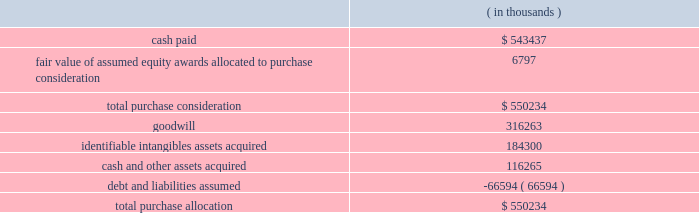Synopsys , inc .
Notes to consolidated financial statements 2014continued acquisition of magma design automation , inc .
( magma ) on february 22 , 2012 , the company acquired all outstanding shares of magma , a chip design software provider , at a per-share price of $ 7.35 .
Additionally , the company assumed unvested restricted stock units ( rsus ) and stock options , collectively called 201cequity awards . 201d the aggregate purchase price was approximately $ 550.2 million .
This acquisition enables the company to more rapidly meet the needs of leading-edge semiconductor designers for more sophisticated design tools .
As of october 31 , 2012 , the total purchase consideration and the preliminary purchase price allocation were as follows: .
Goodwill of $ 316.3 million , which is not deductible for tax purposes , primarily resulted from the company 2019s expectation of sales growth and cost synergies from the integration of magma 2019s technology and operations with the company 2019s technology and operations .
Identifiable intangible assets , consisting primarily of technology , customer relationships , backlog and trademarks , were valued using the income method , and are being amortized over three to ten years .
Acquisition-related costs directly attributable to the business combination totaling $ 33.5 million for fiscal 2012 were expensed as incurred in the consolidated statements of operations and consist primarily of employee separation costs , contract terminations , professional services , and facilities closure costs .
Fair value of equity awards assumed .
The company assumed unvested restricted stock units ( rsus ) and stock options with a fair value of $ 22.2 million .
The black-scholes option-pricing model was used to determine the fair value of these stock options , whereas the fair value of the rsus was based on the market price on the grant date of the instruments .
The black-scholes option-pricing model incorporates various subjective assumptions including expected volatility , expected term and risk-free interest rates .
The expected volatility was estimated by a combination of implied and historical stock price volatility of the options .
Of the total fair value of the equity awards assumed , $ 6.8 million was allocated to the purchase consideration and $ 15.4 million was allocated to future services to be expensed over their remaining service periods on a straight-line basis .
Supplemental pro forma information ( unaudited ) .
The financial information in the table below summarizes the combined results of operations of the company and magma , on a pro forma basis , as though the companies had been combined as of the beginning of fiscal 2011. .
What percentage of total purchase allocation was ? 
Computations: (184300 / 550234)
Answer: 0.33495. 